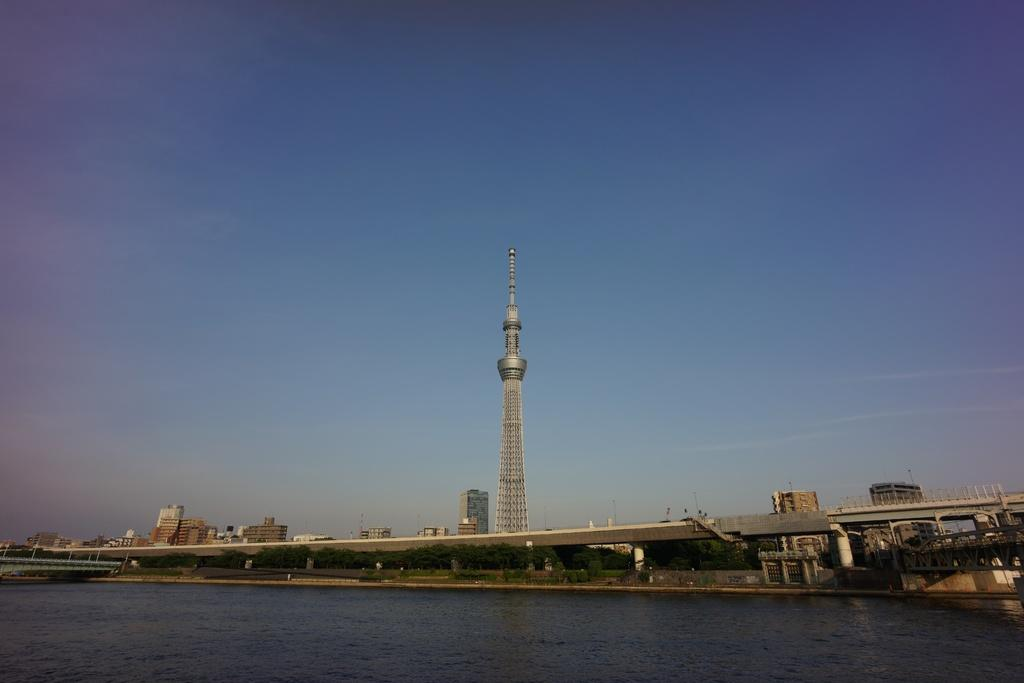What is the main element present in the image? There is water in the image. What type of natural vegetation can be seen in the image? There are trees in the image. What structure is present in the water? There is a bridge in the image. What is located behind the bridge? There is a tower and buildings behind the bridge. What part of the natural environment is visible in the image? The sky is visible in the image. What type of camp can be seen in the image? There is no camp present in the image; it features water, trees, a bridge, a tower, buildings, and the sky. What do people believe about the voyage depicted in the image? There is no voyage depicted in the image, so it is not possible to determine what people might believe about it. 